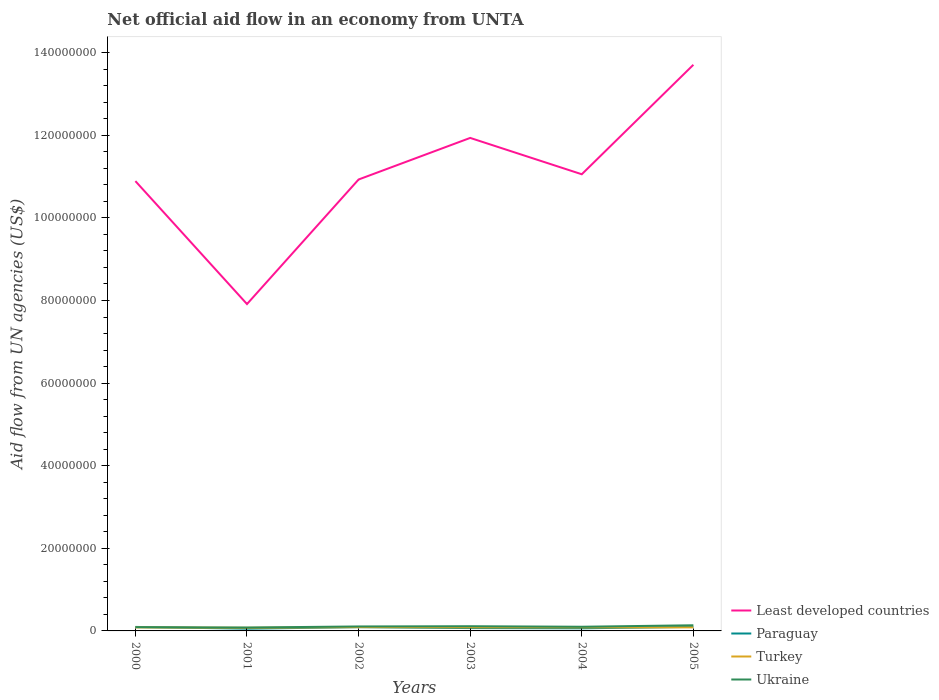How many different coloured lines are there?
Provide a succinct answer. 4. Does the line corresponding to Paraguay intersect with the line corresponding to Least developed countries?
Provide a succinct answer. No. Across all years, what is the maximum net official aid flow in Paraguay?
Make the answer very short. 5.40e+05. In which year was the net official aid flow in Least developed countries maximum?
Your response must be concise. 2001. What is the difference between the highest and the second highest net official aid flow in Least developed countries?
Make the answer very short. 5.79e+07. Is the net official aid flow in Least developed countries strictly greater than the net official aid flow in Turkey over the years?
Your response must be concise. No. Does the graph contain any zero values?
Ensure brevity in your answer.  No. Does the graph contain grids?
Offer a terse response. No. What is the title of the graph?
Make the answer very short. Net official aid flow in an economy from UNTA. What is the label or title of the Y-axis?
Offer a terse response. Aid flow from UN agencies (US$). What is the Aid flow from UN agencies (US$) in Least developed countries in 2000?
Make the answer very short. 1.09e+08. What is the Aid flow from UN agencies (US$) in Paraguay in 2000?
Give a very brief answer. 9.70e+05. What is the Aid flow from UN agencies (US$) in Turkey in 2000?
Offer a terse response. 8.60e+05. What is the Aid flow from UN agencies (US$) of Least developed countries in 2001?
Make the answer very short. 7.91e+07. What is the Aid flow from UN agencies (US$) of Paraguay in 2001?
Keep it short and to the point. 5.40e+05. What is the Aid flow from UN agencies (US$) in Turkey in 2001?
Ensure brevity in your answer.  7.60e+05. What is the Aid flow from UN agencies (US$) in Ukraine in 2001?
Give a very brief answer. 8.20e+05. What is the Aid flow from UN agencies (US$) in Least developed countries in 2002?
Your answer should be very brief. 1.09e+08. What is the Aid flow from UN agencies (US$) of Paraguay in 2002?
Offer a very short reply. 9.10e+05. What is the Aid flow from UN agencies (US$) in Turkey in 2002?
Ensure brevity in your answer.  9.20e+05. What is the Aid flow from UN agencies (US$) of Ukraine in 2002?
Offer a terse response. 1.08e+06. What is the Aid flow from UN agencies (US$) in Least developed countries in 2003?
Provide a short and direct response. 1.19e+08. What is the Aid flow from UN agencies (US$) of Paraguay in 2003?
Your answer should be very brief. 6.90e+05. What is the Aid flow from UN agencies (US$) in Turkey in 2003?
Make the answer very short. 8.60e+05. What is the Aid flow from UN agencies (US$) of Ukraine in 2003?
Your response must be concise. 1.14e+06. What is the Aid flow from UN agencies (US$) in Least developed countries in 2004?
Provide a short and direct response. 1.11e+08. What is the Aid flow from UN agencies (US$) of Paraguay in 2004?
Offer a terse response. 6.30e+05. What is the Aid flow from UN agencies (US$) of Turkey in 2004?
Offer a very short reply. 8.50e+05. What is the Aid flow from UN agencies (US$) of Ukraine in 2004?
Ensure brevity in your answer.  1.01e+06. What is the Aid flow from UN agencies (US$) of Least developed countries in 2005?
Offer a terse response. 1.37e+08. What is the Aid flow from UN agencies (US$) in Paraguay in 2005?
Your answer should be compact. 9.80e+05. What is the Aid flow from UN agencies (US$) in Turkey in 2005?
Make the answer very short. 8.60e+05. What is the Aid flow from UN agencies (US$) in Ukraine in 2005?
Your answer should be compact. 1.37e+06. Across all years, what is the maximum Aid flow from UN agencies (US$) in Least developed countries?
Provide a short and direct response. 1.37e+08. Across all years, what is the maximum Aid flow from UN agencies (US$) of Paraguay?
Provide a short and direct response. 9.80e+05. Across all years, what is the maximum Aid flow from UN agencies (US$) of Turkey?
Your answer should be very brief. 9.20e+05. Across all years, what is the maximum Aid flow from UN agencies (US$) of Ukraine?
Offer a terse response. 1.37e+06. Across all years, what is the minimum Aid flow from UN agencies (US$) in Least developed countries?
Your answer should be very brief. 7.91e+07. Across all years, what is the minimum Aid flow from UN agencies (US$) in Paraguay?
Provide a short and direct response. 5.40e+05. Across all years, what is the minimum Aid flow from UN agencies (US$) in Turkey?
Your response must be concise. 7.60e+05. Across all years, what is the minimum Aid flow from UN agencies (US$) of Ukraine?
Provide a short and direct response. 8.20e+05. What is the total Aid flow from UN agencies (US$) in Least developed countries in the graph?
Provide a short and direct response. 6.64e+08. What is the total Aid flow from UN agencies (US$) in Paraguay in the graph?
Your response must be concise. 4.72e+06. What is the total Aid flow from UN agencies (US$) of Turkey in the graph?
Your answer should be compact. 5.11e+06. What is the total Aid flow from UN agencies (US$) in Ukraine in the graph?
Ensure brevity in your answer.  6.32e+06. What is the difference between the Aid flow from UN agencies (US$) of Least developed countries in 2000 and that in 2001?
Provide a short and direct response. 2.98e+07. What is the difference between the Aid flow from UN agencies (US$) in Paraguay in 2000 and that in 2001?
Offer a very short reply. 4.30e+05. What is the difference between the Aid flow from UN agencies (US$) in Ukraine in 2000 and that in 2001?
Make the answer very short. 8.00e+04. What is the difference between the Aid flow from UN agencies (US$) of Least developed countries in 2000 and that in 2002?
Your answer should be compact. -3.90e+05. What is the difference between the Aid flow from UN agencies (US$) of Paraguay in 2000 and that in 2002?
Provide a short and direct response. 6.00e+04. What is the difference between the Aid flow from UN agencies (US$) of Turkey in 2000 and that in 2002?
Your response must be concise. -6.00e+04. What is the difference between the Aid flow from UN agencies (US$) in Ukraine in 2000 and that in 2002?
Offer a terse response. -1.80e+05. What is the difference between the Aid flow from UN agencies (US$) of Least developed countries in 2000 and that in 2003?
Give a very brief answer. -1.05e+07. What is the difference between the Aid flow from UN agencies (US$) of Paraguay in 2000 and that in 2003?
Keep it short and to the point. 2.80e+05. What is the difference between the Aid flow from UN agencies (US$) of Ukraine in 2000 and that in 2003?
Give a very brief answer. -2.40e+05. What is the difference between the Aid flow from UN agencies (US$) in Least developed countries in 2000 and that in 2004?
Offer a terse response. -1.66e+06. What is the difference between the Aid flow from UN agencies (US$) of Paraguay in 2000 and that in 2004?
Your response must be concise. 3.40e+05. What is the difference between the Aid flow from UN agencies (US$) in Ukraine in 2000 and that in 2004?
Offer a very short reply. -1.10e+05. What is the difference between the Aid flow from UN agencies (US$) of Least developed countries in 2000 and that in 2005?
Make the answer very short. -2.82e+07. What is the difference between the Aid flow from UN agencies (US$) in Paraguay in 2000 and that in 2005?
Keep it short and to the point. -10000. What is the difference between the Aid flow from UN agencies (US$) of Ukraine in 2000 and that in 2005?
Make the answer very short. -4.70e+05. What is the difference between the Aid flow from UN agencies (US$) in Least developed countries in 2001 and that in 2002?
Give a very brief answer. -3.02e+07. What is the difference between the Aid flow from UN agencies (US$) of Paraguay in 2001 and that in 2002?
Your answer should be compact. -3.70e+05. What is the difference between the Aid flow from UN agencies (US$) of Ukraine in 2001 and that in 2002?
Offer a very short reply. -2.60e+05. What is the difference between the Aid flow from UN agencies (US$) of Least developed countries in 2001 and that in 2003?
Provide a short and direct response. -4.02e+07. What is the difference between the Aid flow from UN agencies (US$) in Paraguay in 2001 and that in 2003?
Make the answer very short. -1.50e+05. What is the difference between the Aid flow from UN agencies (US$) in Turkey in 2001 and that in 2003?
Your response must be concise. -1.00e+05. What is the difference between the Aid flow from UN agencies (US$) of Ukraine in 2001 and that in 2003?
Provide a short and direct response. -3.20e+05. What is the difference between the Aid flow from UN agencies (US$) of Least developed countries in 2001 and that in 2004?
Your response must be concise. -3.14e+07. What is the difference between the Aid flow from UN agencies (US$) of Turkey in 2001 and that in 2004?
Provide a succinct answer. -9.00e+04. What is the difference between the Aid flow from UN agencies (US$) of Least developed countries in 2001 and that in 2005?
Make the answer very short. -5.79e+07. What is the difference between the Aid flow from UN agencies (US$) in Paraguay in 2001 and that in 2005?
Ensure brevity in your answer.  -4.40e+05. What is the difference between the Aid flow from UN agencies (US$) of Turkey in 2001 and that in 2005?
Your answer should be very brief. -1.00e+05. What is the difference between the Aid flow from UN agencies (US$) of Ukraine in 2001 and that in 2005?
Provide a short and direct response. -5.50e+05. What is the difference between the Aid flow from UN agencies (US$) in Least developed countries in 2002 and that in 2003?
Provide a short and direct response. -1.01e+07. What is the difference between the Aid flow from UN agencies (US$) in Paraguay in 2002 and that in 2003?
Make the answer very short. 2.20e+05. What is the difference between the Aid flow from UN agencies (US$) in Least developed countries in 2002 and that in 2004?
Offer a terse response. -1.27e+06. What is the difference between the Aid flow from UN agencies (US$) in Turkey in 2002 and that in 2004?
Your answer should be compact. 7.00e+04. What is the difference between the Aid flow from UN agencies (US$) of Ukraine in 2002 and that in 2004?
Provide a succinct answer. 7.00e+04. What is the difference between the Aid flow from UN agencies (US$) of Least developed countries in 2002 and that in 2005?
Make the answer very short. -2.78e+07. What is the difference between the Aid flow from UN agencies (US$) of Ukraine in 2002 and that in 2005?
Keep it short and to the point. -2.90e+05. What is the difference between the Aid flow from UN agencies (US$) of Least developed countries in 2003 and that in 2004?
Make the answer very short. 8.80e+06. What is the difference between the Aid flow from UN agencies (US$) in Paraguay in 2003 and that in 2004?
Offer a very short reply. 6.00e+04. What is the difference between the Aid flow from UN agencies (US$) of Turkey in 2003 and that in 2004?
Ensure brevity in your answer.  10000. What is the difference between the Aid flow from UN agencies (US$) of Ukraine in 2003 and that in 2004?
Offer a terse response. 1.30e+05. What is the difference between the Aid flow from UN agencies (US$) in Least developed countries in 2003 and that in 2005?
Your response must be concise. -1.77e+07. What is the difference between the Aid flow from UN agencies (US$) in Ukraine in 2003 and that in 2005?
Your response must be concise. -2.30e+05. What is the difference between the Aid flow from UN agencies (US$) in Least developed countries in 2004 and that in 2005?
Provide a short and direct response. -2.65e+07. What is the difference between the Aid flow from UN agencies (US$) in Paraguay in 2004 and that in 2005?
Offer a very short reply. -3.50e+05. What is the difference between the Aid flow from UN agencies (US$) in Turkey in 2004 and that in 2005?
Offer a very short reply. -10000. What is the difference between the Aid flow from UN agencies (US$) of Ukraine in 2004 and that in 2005?
Provide a succinct answer. -3.60e+05. What is the difference between the Aid flow from UN agencies (US$) of Least developed countries in 2000 and the Aid flow from UN agencies (US$) of Paraguay in 2001?
Offer a terse response. 1.08e+08. What is the difference between the Aid flow from UN agencies (US$) of Least developed countries in 2000 and the Aid flow from UN agencies (US$) of Turkey in 2001?
Provide a short and direct response. 1.08e+08. What is the difference between the Aid flow from UN agencies (US$) in Least developed countries in 2000 and the Aid flow from UN agencies (US$) in Ukraine in 2001?
Keep it short and to the point. 1.08e+08. What is the difference between the Aid flow from UN agencies (US$) in Paraguay in 2000 and the Aid flow from UN agencies (US$) in Turkey in 2001?
Give a very brief answer. 2.10e+05. What is the difference between the Aid flow from UN agencies (US$) of Turkey in 2000 and the Aid flow from UN agencies (US$) of Ukraine in 2001?
Provide a succinct answer. 4.00e+04. What is the difference between the Aid flow from UN agencies (US$) in Least developed countries in 2000 and the Aid flow from UN agencies (US$) in Paraguay in 2002?
Your answer should be compact. 1.08e+08. What is the difference between the Aid flow from UN agencies (US$) in Least developed countries in 2000 and the Aid flow from UN agencies (US$) in Turkey in 2002?
Your answer should be compact. 1.08e+08. What is the difference between the Aid flow from UN agencies (US$) in Least developed countries in 2000 and the Aid flow from UN agencies (US$) in Ukraine in 2002?
Make the answer very short. 1.08e+08. What is the difference between the Aid flow from UN agencies (US$) in Paraguay in 2000 and the Aid flow from UN agencies (US$) in Turkey in 2002?
Give a very brief answer. 5.00e+04. What is the difference between the Aid flow from UN agencies (US$) in Paraguay in 2000 and the Aid flow from UN agencies (US$) in Ukraine in 2002?
Make the answer very short. -1.10e+05. What is the difference between the Aid flow from UN agencies (US$) of Least developed countries in 2000 and the Aid flow from UN agencies (US$) of Paraguay in 2003?
Your answer should be compact. 1.08e+08. What is the difference between the Aid flow from UN agencies (US$) of Least developed countries in 2000 and the Aid flow from UN agencies (US$) of Turkey in 2003?
Ensure brevity in your answer.  1.08e+08. What is the difference between the Aid flow from UN agencies (US$) in Least developed countries in 2000 and the Aid flow from UN agencies (US$) in Ukraine in 2003?
Make the answer very short. 1.08e+08. What is the difference between the Aid flow from UN agencies (US$) of Turkey in 2000 and the Aid flow from UN agencies (US$) of Ukraine in 2003?
Provide a short and direct response. -2.80e+05. What is the difference between the Aid flow from UN agencies (US$) of Least developed countries in 2000 and the Aid flow from UN agencies (US$) of Paraguay in 2004?
Offer a terse response. 1.08e+08. What is the difference between the Aid flow from UN agencies (US$) in Least developed countries in 2000 and the Aid flow from UN agencies (US$) in Turkey in 2004?
Provide a short and direct response. 1.08e+08. What is the difference between the Aid flow from UN agencies (US$) of Least developed countries in 2000 and the Aid flow from UN agencies (US$) of Ukraine in 2004?
Your answer should be very brief. 1.08e+08. What is the difference between the Aid flow from UN agencies (US$) in Paraguay in 2000 and the Aid flow from UN agencies (US$) in Ukraine in 2004?
Offer a terse response. -4.00e+04. What is the difference between the Aid flow from UN agencies (US$) in Turkey in 2000 and the Aid flow from UN agencies (US$) in Ukraine in 2004?
Make the answer very short. -1.50e+05. What is the difference between the Aid flow from UN agencies (US$) in Least developed countries in 2000 and the Aid flow from UN agencies (US$) in Paraguay in 2005?
Offer a terse response. 1.08e+08. What is the difference between the Aid flow from UN agencies (US$) in Least developed countries in 2000 and the Aid flow from UN agencies (US$) in Turkey in 2005?
Your answer should be compact. 1.08e+08. What is the difference between the Aid flow from UN agencies (US$) in Least developed countries in 2000 and the Aid flow from UN agencies (US$) in Ukraine in 2005?
Your answer should be very brief. 1.08e+08. What is the difference between the Aid flow from UN agencies (US$) of Paraguay in 2000 and the Aid flow from UN agencies (US$) of Ukraine in 2005?
Your answer should be very brief. -4.00e+05. What is the difference between the Aid flow from UN agencies (US$) of Turkey in 2000 and the Aid flow from UN agencies (US$) of Ukraine in 2005?
Offer a very short reply. -5.10e+05. What is the difference between the Aid flow from UN agencies (US$) in Least developed countries in 2001 and the Aid flow from UN agencies (US$) in Paraguay in 2002?
Provide a succinct answer. 7.82e+07. What is the difference between the Aid flow from UN agencies (US$) in Least developed countries in 2001 and the Aid flow from UN agencies (US$) in Turkey in 2002?
Make the answer very short. 7.82e+07. What is the difference between the Aid flow from UN agencies (US$) of Least developed countries in 2001 and the Aid flow from UN agencies (US$) of Ukraine in 2002?
Your response must be concise. 7.81e+07. What is the difference between the Aid flow from UN agencies (US$) of Paraguay in 2001 and the Aid flow from UN agencies (US$) of Turkey in 2002?
Your response must be concise. -3.80e+05. What is the difference between the Aid flow from UN agencies (US$) in Paraguay in 2001 and the Aid flow from UN agencies (US$) in Ukraine in 2002?
Give a very brief answer. -5.40e+05. What is the difference between the Aid flow from UN agencies (US$) of Turkey in 2001 and the Aid flow from UN agencies (US$) of Ukraine in 2002?
Keep it short and to the point. -3.20e+05. What is the difference between the Aid flow from UN agencies (US$) of Least developed countries in 2001 and the Aid flow from UN agencies (US$) of Paraguay in 2003?
Offer a very short reply. 7.84e+07. What is the difference between the Aid flow from UN agencies (US$) of Least developed countries in 2001 and the Aid flow from UN agencies (US$) of Turkey in 2003?
Ensure brevity in your answer.  7.83e+07. What is the difference between the Aid flow from UN agencies (US$) in Least developed countries in 2001 and the Aid flow from UN agencies (US$) in Ukraine in 2003?
Keep it short and to the point. 7.80e+07. What is the difference between the Aid flow from UN agencies (US$) of Paraguay in 2001 and the Aid flow from UN agencies (US$) of Turkey in 2003?
Offer a terse response. -3.20e+05. What is the difference between the Aid flow from UN agencies (US$) of Paraguay in 2001 and the Aid flow from UN agencies (US$) of Ukraine in 2003?
Keep it short and to the point. -6.00e+05. What is the difference between the Aid flow from UN agencies (US$) of Turkey in 2001 and the Aid flow from UN agencies (US$) of Ukraine in 2003?
Make the answer very short. -3.80e+05. What is the difference between the Aid flow from UN agencies (US$) of Least developed countries in 2001 and the Aid flow from UN agencies (US$) of Paraguay in 2004?
Offer a very short reply. 7.85e+07. What is the difference between the Aid flow from UN agencies (US$) of Least developed countries in 2001 and the Aid flow from UN agencies (US$) of Turkey in 2004?
Give a very brief answer. 7.83e+07. What is the difference between the Aid flow from UN agencies (US$) of Least developed countries in 2001 and the Aid flow from UN agencies (US$) of Ukraine in 2004?
Offer a very short reply. 7.81e+07. What is the difference between the Aid flow from UN agencies (US$) in Paraguay in 2001 and the Aid flow from UN agencies (US$) in Turkey in 2004?
Provide a succinct answer. -3.10e+05. What is the difference between the Aid flow from UN agencies (US$) of Paraguay in 2001 and the Aid flow from UN agencies (US$) of Ukraine in 2004?
Make the answer very short. -4.70e+05. What is the difference between the Aid flow from UN agencies (US$) in Turkey in 2001 and the Aid flow from UN agencies (US$) in Ukraine in 2004?
Offer a very short reply. -2.50e+05. What is the difference between the Aid flow from UN agencies (US$) in Least developed countries in 2001 and the Aid flow from UN agencies (US$) in Paraguay in 2005?
Keep it short and to the point. 7.82e+07. What is the difference between the Aid flow from UN agencies (US$) of Least developed countries in 2001 and the Aid flow from UN agencies (US$) of Turkey in 2005?
Keep it short and to the point. 7.83e+07. What is the difference between the Aid flow from UN agencies (US$) in Least developed countries in 2001 and the Aid flow from UN agencies (US$) in Ukraine in 2005?
Make the answer very short. 7.78e+07. What is the difference between the Aid flow from UN agencies (US$) of Paraguay in 2001 and the Aid flow from UN agencies (US$) of Turkey in 2005?
Your response must be concise. -3.20e+05. What is the difference between the Aid flow from UN agencies (US$) of Paraguay in 2001 and the Aid flow from UN agencies (US$) of Ukraine in 2005?
Offer a very short reply. -8.30e+05. What is the difference between the Aid flow from UN agencies (US$) in Turkey in 2001 and the Aid flow from UN agencies (US$) in Ukraine in 2005?
Your answer should be very brief. -6.10e+05. What is the difference between the Aid flow from UN agencies (US$) of Least developed countries in 2002 and the Aid flow from UN agencies (US$) of Paraguay in 2003?
Offer a terse response. 1.09e+08. What is the difference between the Aid flow from UN agencies (US$) of Least developed countries in 2002 and the Aid flow from UN agencies (US$) of Turkey in 2003?
Make the answer very short. 1.08e+08. What is the difference between the Aid flow from UN agencies (US$) in Least developed countries in 2002 and the Aid flow from UN agencies (US$) in Ukraine in 2003?
Provide a succinct answer. 1.08e+08. What is the difference between the Aid flow from UN agencies (US$) in Paraguay in 2002 and the Aid flow from UN agencies (US$) in Turkey in 2003?
Your response must be concise. 5.00e+04. What is the difference between the Aid flow from UN agencies (US$) in Paraguay in 2002 and the Aid flow from UN agencies (US$) in Ukraine in 2003?
Offer a very short reply. -2.30e+05. What is the difference between the Aid flow from UN agencies (US$) in Turkey in 2002 and the Aid flow from UN agencies (US$) in Ukraine in 2003?
Your answer should be compact. -2.20e+05. What is the difference between the Aid flow from UN agencies (US$) of Least developed countries in 2002 and the Aid flow from UN agencies (US$) of Paraguay in 2004?
Ensure brevity in your answer.  1.09e+08. What is the difference between the Aid flow from UN agencies (US$) of Least developed countries in 2002 and the Aid flow from UN agencies (US$) of Turkey in 2004?
Your response must be concise. 1.08e+08. What is the difference between the Aid flow from UN agencies (US$) of Least developed countries in 2002 and the Aid flow from UN agencies (US$) of Ukraine in 2004?
Keep it short and to the point. 1.08e+08. What is the difference between the Aid flow from UN agencies (US$) in Paraguay in 2002 and the Aid flow from UN agencies (US$) in Turkey in 2004?
Keep it short and to the point. 6.00e+04. What is the difference between the Aid flow from UN agencies (US$) in Paraguay in 2002 and the Aid flow from UN agencies (US$) in Ukraine in 2004?
Your answer should be very brief. -1.00e+05. What is the difference between the Aid flow from UN agencies (US$) of Turkey in 2002 and the Aid flow from UN agencies (US$) of Ukraine in 2004?
Keep it short and to the point. -9.00e+04. What is the difference between the Aid flow from UN agencies (US$) of Least developed countries in 2002 and the Aid flow from UN agencies (US$) of Paraguay in 2005?
Ensure brevity in your answer.  1.08e+08. What is the difference between the Aid flow from UN agencies (US$) in Least developed countries in 2002 and the Aid flow from UN agencies (US$) in Turkey in 2005?
Ensure brevity in your answer.  1.08e+08. What is the difference between the Aid flow from UN agencies (US$) in Least developed countries in 2002 and the Aid flow from UN agencies (US$) in Ukraine in 2005?
Keep it short and to the point. 1.08e+08. What is the difference between the Aid flow from UN agencies (US$) in Paraguay in 2002 and the Aid flow from UN agencies (US$) in Turkey in 2005?
Keep it short and to the point. 5.00e+04. What is the difference between the Aid flow from UN agencies (US$) in Paraguay in 2002 and the Aid flow from UN agencies (US$) in Ukraine in 2005?
Offer a very short reply. -4.60e+05. What is the difference between the Aid flow from UN agencies (US$) of Turkey in 2002 and the Aid flow from UN agencies (US$) of Ukraine in 2005?
Your answer should be compact. -4.50e+05. What is the difference between the Aid flow from UN agencies (US$) in Least developed countries in 2003 and the Aid flow from UN agencies (US$) in Paraguay in 2004?
Keep it short and to the point. 1.19e+08. What is the difference between the Aid flow from UN agencies (US$) in Least developed countries in 2003 and the Aid flow from UN agencies (US$) in Turkey in 2004?
Offer a very short reply. 1.19e+08. What is the difference between the Aid flow from UN agencies (US$) in Least developed countries in 2003 and the Aid flow from UN agencies (US$) in Ukraine in 2004?
Provide a succinct answer. 1.18e+08. What is the difference between the Aid flow from UN agencies (US$) of Paraguay in 2003 and the Aid flow from UN agencies (US$) of Ukraine in 2004?
Make the answer very short. -3.20e+05. What is the difference between the Aid flow from UN agencies (US$) in Least developed countries in 2003 and the Aid flow from UN agencies (US$) in Paraguay in 2005?
Keep it short and to the point. 1.18e+08. What is the difference between the Aid flow from UN agencies (US$) in Least developed countries in 2003 and the Aid flow from UN agencies (US$) in Turkey in 2005?
Your response must be concise. 1.19e+08. What is the difference between the Aid flow from UN agencies (US$) in Least developed countries in 2003 and the Aid flow from UN agencies (US$) in Ukraine in 2005?
Ensure brevity in your answer.  1.18e+08. What is the difference between the Aid flow from UN agencies (US$) in Paraguay in 2003 and the Aid flow from UN agencies (US$) in Turkey in 2005?
Offer a very short reply. -1.70e+05. What is the difference between the Aid flow from UN agencies (US$) of Paraguay in 2003 and the Aid flow from UN agencies (US$) of Ukraine in 2005?
Give a very brief answer. -6.80e+05. What is the difference between the Aid flow from UN agencies (US$) of Turkey in 2003 and the Aid flow from UN agencies (US$) of Ukraine in 2005?
Your answer should be very brief. -5.10e+05. What is the difference between the Aid flow from UN agencies (US$) of Least developed countries in 2004 and the Aid flow from UN agencies (US$) of Paraguay in 2005?
Offer a very short reply. 1.10e+08. What is the difference between the Aid flow from UN agencies (US$) of Least developed countries in 2004 and the Aid flow from UN agencies (US$) of Turkey in 2005?
Your answer should be very brief. 1.10e+08. What is the difference between the Aid flow from UN agencies (US$) in Least developed countries in 2004 and the Aid flow from UN agencies (US$) in Ukraine in 2005?
Provide a succinct answer. 1.09e+08. What is the difference between the Aid flow from UN agencies (US$) in Paraguay in 2004 and the Aid flow from UN agencies (US$) in Turkey in 2005?
Give a very brief answer. -2.30e+05. What is the difference between the Aid flow from UN agencies (US$) of Paraguay in 2004 and the Aid flow from UN agencies (US$) of Ukraine in 2005?
Give a very brief answer. -7.40e+05. What is the difference between the Aid flow from UN agencies (US$) in Turkey in 2004 and the Aid flow from UN agencies (US$) in Ukraine in 2005?
Give a very brief answer. -5.20e+05. What is the average Aid flow from UN agencies (US$) in Least developed countries per year?
Your answer should be compact. 1.11e+08. What is the average Aid flow from UN agencies (US$) in Paraguay per year?
Your response must be concise. 7.87e+05. What is the average Aid flow from UN agencies (US$) of Turkey per year?
Your response must be concise. 8.52e+05. What is the average Aid flow from UN agencies (US$) of Ukraine per year?
Offer a terse response. 1.05e+06. In the year 2000, what is the difference between the Aid flow from UN agencies (US$) in Least developed countries and Aid flow from UN agencies (US$) in Paraguay?
Provide a succinct answer. 1.08e+08. In the year 2000, what is the difference between the Aid flow from UN agencies (US$) in Least developed countries and Aid flow from UN agencies (US$) in Turkey?
Provide a short and direct response. 1.08e+08. In the year 2000, what is the difference between the Aid flow from UN agencies (US$) of Least developed countries and Aid flow from UN agencies (US$) of Ukraine?
Your response must be concise. 1.08e+08. In the year 2000, what is the difference between the Aid flow from UN agencies (US$) in Paraguay and Aid flow from UN agencies (US$) in Ukraine?
Offer a terse response. 7.00e+04. In the year 2001, what is the difference between the Aid flow from UN agencies (US$) of Least developed countries and Aid flow from UN agencies (US$) of Paraguay?
Offer a terse response. 7.86e+07. In the year 2001, what is the difference between the Aid flow from UN agencies (US$) of Least developed countries and Aid flow from UN agencies (US$) of Turkey?
Give a very brief answer. 7.84e+07. In the year 2001, what is the difference between the Aid flow from UN agencies (US$) in Least developed countries and Aid flow from UN agencies (US$) in Ukraine?
Offer a very short reply. 7.83e+07. In the year 2001, what is the difference between the Aid flow from UN agencies (US$) of Paraguay and Aid flow from UN agencies (US$) of Ukraine?
Ensure brevity in your answer.  -2.80e+05. In the year 2001, what is the difference between the Aid flow from UN agencies (US$) in Turkey and Aid flow from UN agencies (US$) in Ukraine?
Offer a very short reply. -6.00e+04. In the year 2002, what is the difference between the Aid flow from UN agencies (US$) in Least developed countries and Aid flow from UN agencies (US$) in Paraguay?
Give a very brief answer. 1.08e+08. In the year 2002, what is the difference between the Aid flow from UN agencies (US$) of Least developed countries and Aid flow from UN agencies (US$) of Turkey?
Offer a very short reply. 1.08e+08. In the year 2002, what is the difference between the Aid flow from UN agencies (US$) in Least developed countries and Aid flow from UN agencies (US$) in Ukraine?
Keep it short and to the point. 1.08e+08. In the year 2002, what is the difference between the Aid flow from UN agencies (US$) in Paraguay and Aid flow from UN agencies (US$) in Ukraine?
Make the answer very short. -1.70e+05. In the year 2002, what is the difference between the Aid flow from UN agencies (US$) of Turkey and Aid flow from UN agencies (US$) of Ukraine?
Your response must be concise. -1.60e+05. In the year 2003, what is the difference between the Aid flow from UN agencies (US$) in Least developed countries and Aid flow from UN agencies (US$) in Paraguay?
Offer a terse response. 1.19e+08. In the year 2003, what is the difference between the Aid flow from UN agencies (US$) in Least developed countries and Aid flow from UN agencies (US$) in Turkey?
Make the answer very short. 1.19e+08. In the year 2003, what is the difference between the Aid flow from UN agencies (US$) of Least developed countries and Aid flow from UN agencies (US$) of Ukraine?
Your answer should be very brief. 1.18e+08. In the year 2003, what is the difference between the Aid flow from UN agencies (US$) in Paraguay and Aid flow from UN agencies (US$) in Turkey?
Offer a very short reply. -1.70e+05. In the year 2003, what is the difference between the Aid flow from UN agencies (US$) in Paraguay and Aid flow from UN agencies (US$) in Ukraine?
Give a very brief answer. -4.50e+05. In the year 2003, what is the difference between the Aid flow from UN agencies (US$) of Turkey and Aid flow from UN agencies (US$) of Ukraine?
Your answer should be compact. -2.80e+05. In the year 2004, what is the difference between the Aid flow from UN agencies (US$) of Least developed countries and Aid flow from UN agencies (US$) of Paraguay?
Your answer should be very brief. 1.10e+08. In the year 2004, what is the difference between the Aid flow from UN agencies (US$) of Least developed countries and Aid flow from UN agencies (US$) of Turkey?
Give a very brief answer. 1.10e+08. In the year 2004, what is the difference between the Aid flow from UN agencies (US$) of Least developed countries and Aid flow from UN agencies (US$) of Ukraine?
Offer a very short reply. 1.10e+08. In the year 2004, what is the difference between the Aid flow from UN agencies (US$) of Paraguay and Aid flow from UN agencies (US$) of Ukraine?
Your answer should be compact. -3.80e+05. In the year 2004, what is the difference between the Aid flow from UN agencies (US$) in Turkey and Aid flow from UN agencies (US$) in Ukraine?
Offer a terse response. -1.60e+05. In the year 2005, what is the difference between the Aid flow from UN agencies (US$) in Least developed countries and Aid flow from UN agencies (US$) in Paraguay?
Provide a succinct answer. 1.36e+08. In the year 2005, what is the difference between the Aid flow from UN agencies (US$) of Least developed countries and Aid flow from UN agencies (US$) of Turkey?
Offer a terse response. 1.36e+08. In the year 2005, what is the difference between the Aid flow from UN agencies (US$) of Least developed countries and Aid flow from UN agencies (US$) of Ukraine?
Your answer should be compact. 1.36e+08. In the year 2005, what is the difference between the Aid flow from UN agencies (US$) in Paraguay and Aid flow from UN agencies (US$) in Ukraine?
Ensure brevity in your answer.  -3.90e+05. In the year 2005, what is the difference between the Aid flow from UN agencies (US$) of Turkey and Aid flow from UN agencies (US$) of Ukraine?
Offer a terse response. -5.10e+05. What is the ratio of the Aid flow from UN agencies (US$) of Least developed countries in 2000 to that in 2001?
Keep it short and to the point. 1.38. What is the ratio of the Aid flow from UN agencies (US$) of Paraguay in 2000 to that in 2001?
Your answer should be compact. 1.8. What is the ratio of the Aid flow from UN agencies (US$) in Turkey in 2000 to that in 2001?
Keep it short and to the point. 1.13. What is the ratio of the Aid flow from UN agencies (US$) of Ukraine in 2000 to that in 2001?
Give a very brief answer. 1.1. What is the ratio of the Aid flow from UN agencies (US$) of Paraguay in 2000 to that in 2002?
Keep it short and to the point. 1.07. What is the ratio of the Aid flow from UN agencies (US$) of Turkey in 2000 to that in 2002?
Provide a succinct answer. 0.93. What is the ratio of the Aid flow from UN agencies (US$) of Ukraine in 2000 to that in 2002?
Ensure brevity in your answer.  0.83. What is the ratio of the Aid flow from UN agencies (US$) of Least developed countries in 2000 to that in 2003?
Ensure brevity in your answer.  0.91. What is the ratio of the Aid flow from UN agencies (US$) of Paraguay in 2000 to that in 2003?
Offer a terse response. 1.41. What is the ratio of the Aid flow from UN agencies (US$) of Turkey in 2000 to that in 2003?
Offer a very short reply. 1. What is the ratio of the Aid flow from UN agencies (US$) in Ukraine in 2000 to that in 2003?
Provide a short and direct response. 0.79. What is the ratio of the Aid flow from UN agencies (US$) in Least developed countries in 2000 to that in 2004?
Provide a short and direct response. 0.98. What is the ratio of the Aid flow from UN agencies (US$) of Paraguay in 2000 to that in 2004?
Offer a terse response. 1.54. What is the ratio of the Aid flow from UN agencies (US$) in Turkey in 2000 to that in 2004?
Ensure brevity in your answer.  1.01. What is the ratio of the Aid flow from UN agencies (US$) of Ukraine in 2000 to that in 2004?
Your answer should be very brief. 0.89. What is the ratio of the Aid flow from UN agencies (US$) in Least developed countries in 2000 to that in 2005?
Make the answer very short. 0.79. What is the ratio of the Aid flow from UN agencies (US$) in Turkey in 2000 to that in 2005?
Your answer should be very brief. 1. What is the ratio of the Aid flow from UN agencies (US$) of Ukraine in 2000 to that in 2005?
Give a very brief answer. 0.66. What is the ratio of the Aid flow from UN agencies (US$) in Least developed countries in 2001 to that in 2002?
Your response must be concise. 0.72. What is the ratio of the Aid flow from UN agencies (US$) of Paraguay in 2001 to that in 2002?
Provide a short and direct response. 0.59. What is the ratio of the Aid flow from UN agencies (US$) in Turkey in 2001 to that in 2002?
Provide a succinct answer. 0.83. What is the ratio of the Aid flow from UN agencies (US$) of Ukraine in 2001 to that in 2002?
Ensure brevity in your answer.  0.76. What is the ratio of the Aid flow from UN agencies (US$) in Least developed countries in 2001 to that in 2003?
Provide a succinct answer. 0.66. What is the ratio of the Aid flow from UN agencies (US$) in Paraguay in 2001 to that in 2003?
Make the answer very short. 0.78. What is the ratio of the Aid flow from UN agencies (US$) of Turkey in 2001 to that in 2003?
Keep it short and to the point. 0.88. What is the ratio of the Aid flow from UN agencies (US$) in Ukraine in 2001 to that in 2003?
Provide a short and direct response. 0.72. What is the ratio of the Aid flow from UN agencies (US$) of Least developed countries in 2001 to that in 2004?
Offer a terse response. 0.72. What is the ratio of the Aid flow from UN agencies (US$) of Paraguay in 2001 to that in 2004?
Give a very brief answer. 0.86. What is the ratio of the Aid flow from UN agencies (US$) in Turkey in 2001 to that in 2004?
Your answer should be very brief. 0.89. What is the ratio of the Aid flow from UN agencies (US$) of Ukraine in 2001 to that in 2004?
Your answer should be compact. 0.81. What is the ratio of the Aid flow from UN agencies (US$) of Least developed countries in 2001 to that in 2005?
Your response must be concise. 0.58. What is the ratio of the Aid flow from UN agencies (US$) in Paraguay in 2001 to that in 2005?
Make the answer very short. 0.55. What is the ratio of the Aid flow from UN agencies (US$) in Turkey in 2001 to that in 2005?
Your answer should be compact. 0.88. What is the ratio of the Aid flow from UN agencies (US$) of Ukraine in 2001 to that in 2005?
Your answer should be compact. 0.6. What is the ratio of the Aid flow from UN agencies (US$) in Least developed countries in 2002 to that in 2003?
Give a very brief answer. 0.92. What is the ratio of the Aid flow from UN agencies (US$) in Paraguay in 2002 to that in 2003?
Keep it short and to the point. 1.32. What is the ratio of the Aid flow from UN agencies (US$) of Turkey in 2002 to that in 2003?
Your answer should be compact. 1.07. What is the ratio of the Aid flow from UN agencies (US$) of Ukraine in 2002 to that in 2003?
Give a very brief answer. 0.95. What is the ratio of the Aid flow from UN agencies (US$) of Least developed countries in 2002 to that in 2004?
Provide a short and direct response. 0.99. What is the ratio of the Aid flow from UN agencies (US$) in Paraguay in 2002 to that in 2004?
Make the answer very short. 1.44. What is the ratio of the Aid flow from UN agencies (US$) in Turkey in 2002 to that in 2004?
Ensure brevity in your answer.  1.08. What is the ratio of the Aid flow from UN agencies (US$) in Ukraine in 2002 to that in 2004?
Ensure brevity in your answer.  1.07. What is the ratio of the Aid flow from UN agencies (US$) in Least developed countries in 2002 to that in 2005?
Your answer should be compact. 0.8. What is the ratio of the Aid flow from UN agencies (US$) of Turkey in 2002 to that in 2005?
Ensure brevity in your answer.  1.07. What is the ratio of the Aid flow from UN agencies (US$) in Ukraine in 2002 to that in 2005?
Your answer should be compact. 0.79. What is the ratio of the Aid flow from UN agencies (US$) in Least developed countries in 2003 to that in 2004?
Keep it short and to the point. 1.08. What is the ratio of the Aid flow from UN agencies (US$) of Paraguay in 2003 to that in 2004?
Your answer should be very brief. 1.1. What is the ratio of the Aid flow from UN agencies (US$) in Turkey in 2003 to that in 2004?
Ensure brevity in your answer.  1.01. What is the ratio of the Aid flow from UN agencies (US$) of Ukraine in 2003 to that in 2004?
Your answer should be very brief. 1.13. What is the ratio of the Aid flow from UN agencies (US$) in Least developed countries in 2003 to that in 2005?
Offer a very short reply. 0.87. What is the ratio of the Aid flow from UN agencies (US$) of Paraguay in 2003 to that in 2005?
Your answer should be very brief. 0.7. What is the ratio of the Aid flow from UN agencies (US$) of Ukraine in 2003 to that in 2005?
Offer a very short reply. 0.83. What is the ratio of the Aid flow from UN agencies (US$) in Least developed countries in 2004 to that in 2005?
Ensure brevity in your answer.  0.81. What is the ratio of the Aid flow from UN agencies (US$) in Paraguay in 2004 to that in 2005?
Give a very brief answer. 0.64. What is the ratio of the Aid flow from UN agencies (US$) of Turkey in 2004 to that in 2005?
Provide a short and direct response. 0.99. What is the ratio of the Aid flow from UN agencies (US$) of Ukraine in 2004 to that in 2005?
Your answer should be very brief. 0.74. What is the difference between the highest and the second highest Aid flow from UN agencies (US$) in Least developed countries?
Give a very brief answer. 1.77e+07. What is the difference between the highest and the second highest Aid flow from UN agencies (US$) of Turkey?
Keep it short and to the point. 6.00e+04. What is the difference between the highest and the second highest Aid flow from UN agencies (US$) of Ukraine?
Ensure brevity in your answer.  2.30e+05. What is the difference between the highest and the lowest Aid flow from UN agencies (US$) in Least developed countries?
Offer a very short reply. 5.79e+07. What is the difference between the highest and the lowest Aid flow from UN agencies (US$) in Ukraine?
Keep it short and to the point. 5.50e+05. 